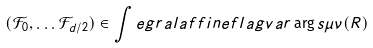Convert formula to latex. <formula><loc_0><loc_0><loc_500><loc_500>( \mathcal { F } _ { 0 } , \dots \mathcal { F } _ { d / 2 } ) \in \int e g r a l a f f i n e f l a g v a r \arg s { \mu } { \nu } ( R )</formula> 